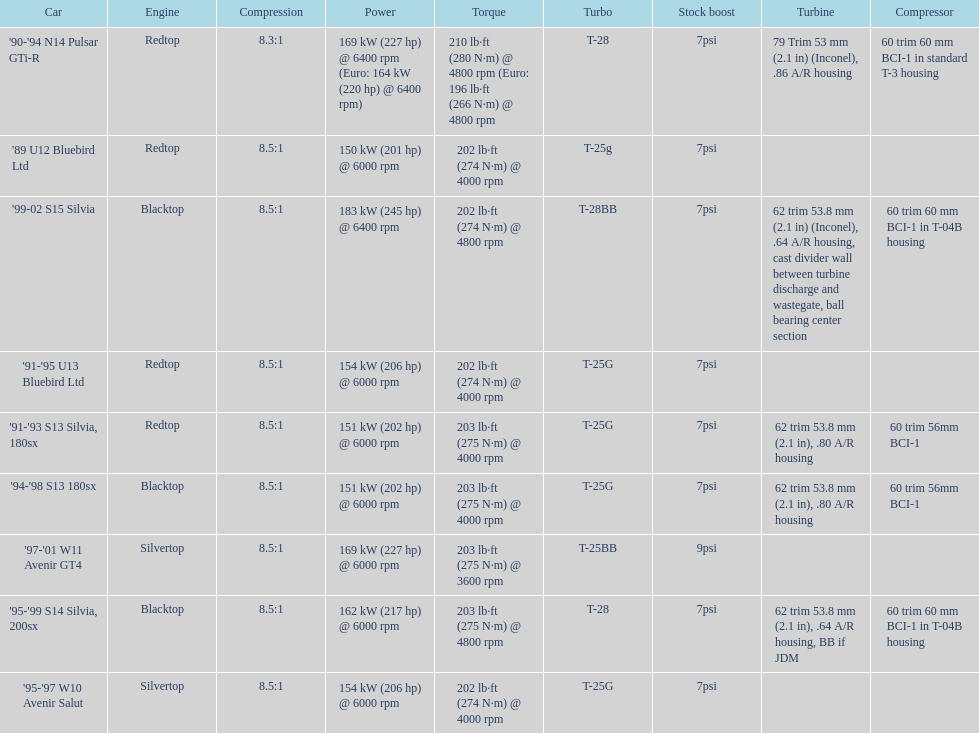How many models used the redtop engine? 4. 